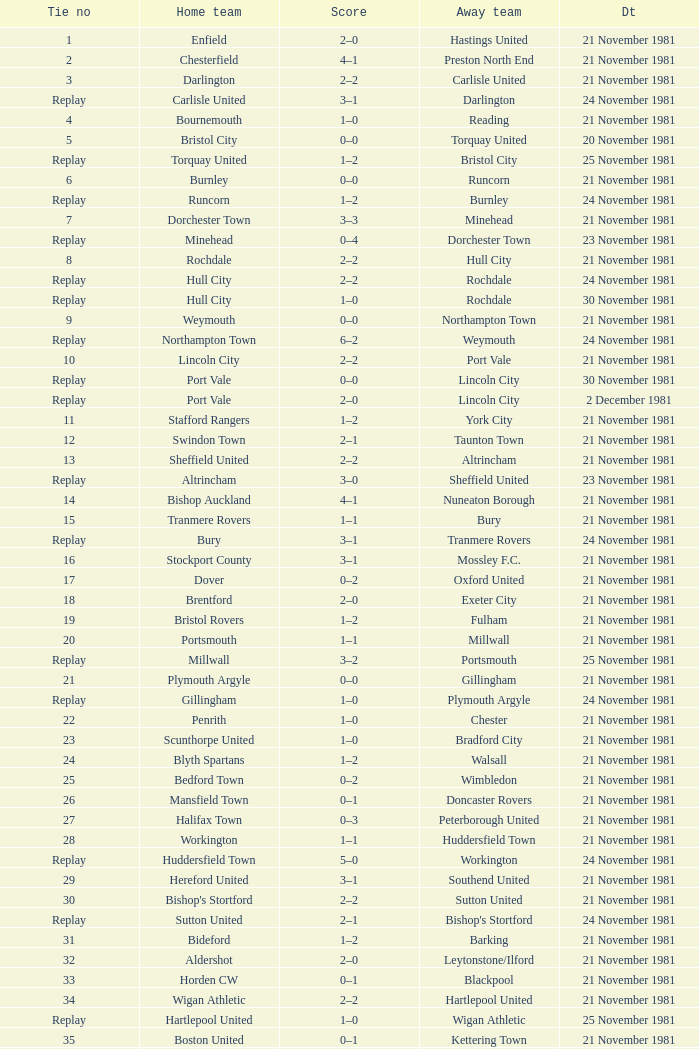Minehead has what tie number? Replay. 